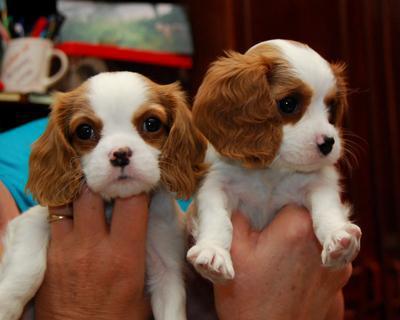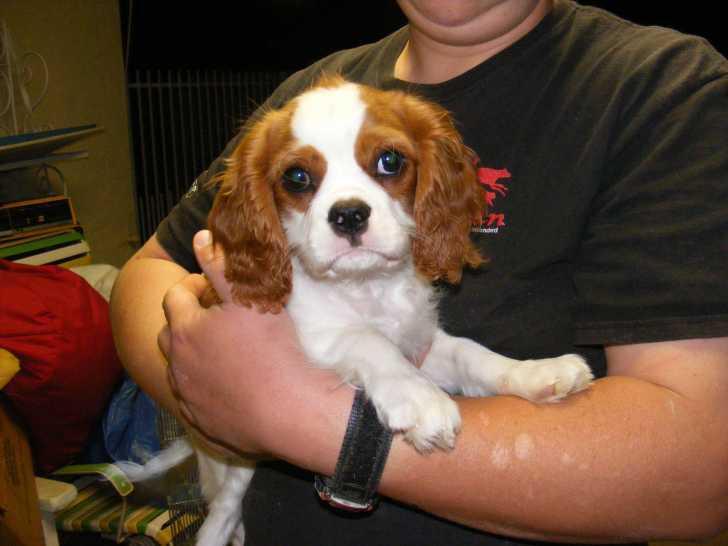The first image is the image on the left, the second image is the image on the right. Evaluate the accuracy of this statement regarding the images: "A person is holding up two dogs in the image on the left.". Is it true? Answer yes or no. Yes. The first image is the image on the left, the second image is the image on the right. For the images shown, is this caption "The right image shows a small brown and white dog with a bow on its head" true? Answer yes or no. No. 